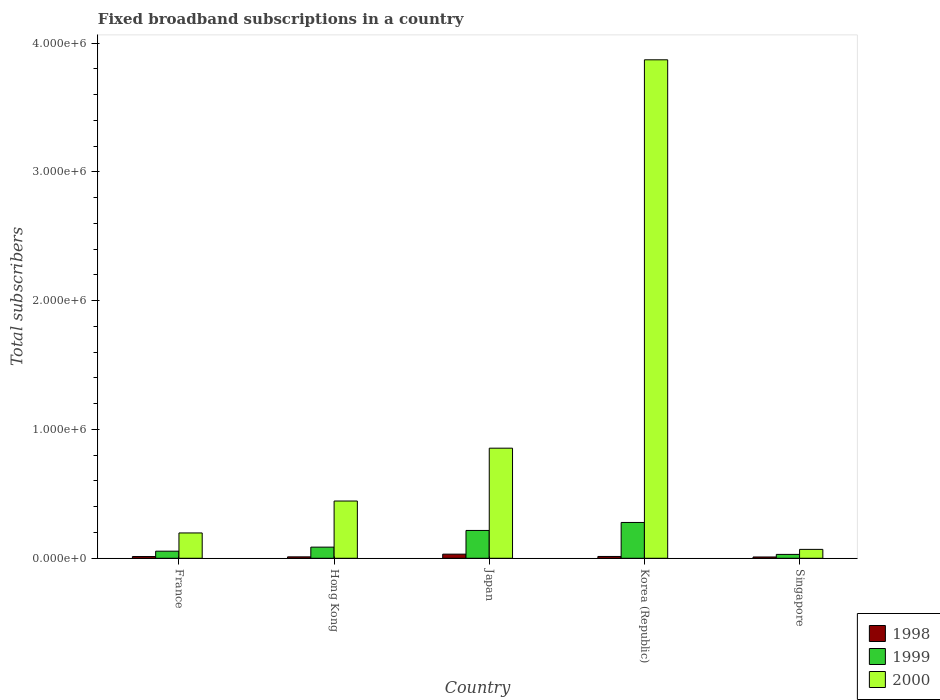How many groups of bars are there?
Your answer should be very brief. 5. Are the number of bars on each tick of the X-axis equal?
Provide a short and direct response. Yes. How many bars are there on the 3rd tick from the left?
Your answer should be very brief. 3. In how many cases, is the number of bars for a given country not equal to the number of legend labels?
Your answer should be compact. 0. What is the number of broadband subscriptions in 1999 in Singapore?
Your answer should be very brief. 3.00e+04. Across all countries, what is the maximum number of broadband subscriptions in 1999?
Ensure brevity in your answer.  2.78e+05. Across all countries, what is the minimum number of broadband subscriptions in 2000?
Your response must be concise. 6.90e+04. In which country was the number of broadband subscriptions in 1999 maximum?
Keep it short and to the point. Korea (Republic). In which country was the number of broadband subscriptions in 2000 minimum?
Your response must be concise. Singapore. What is the total number of broadband subscriptions in 2000 in the graph?
Your answer should be compact. 5.43e+06. What is the difference between the number of broadband subscriptions in 1998 in France and that in Hong Kong?
Offer a very short reply. 2464. What is the difference between the number of broadband subscriptions in 2000 in Singapore and the number of broadband subscriptions in 1999 in Japan?
Give a very brief answer. -1.47e+05. What is the average number of broadband subscriptions in 1999 per country?
Ensure brevity in your answer.  1.33e+05. What is the difference between the number of broadband subscriptions of/in 1999 and number of broadband subscriptions of/in 1998 in Hong Kong?
Offer a terse response. 7.55e+04. What is the ratio of the number of broadband subscriptions in 1999 in France to that in Singapore?
Ensure brevity in your answer.  1.83. Is the difference between the number of broadband subscriptions in 1999 in Korea (Republic) and Singapore greater than the difference between the number of broadband subscriptions in 1998 in Korea (Republic) and Singapore?
Make the answer very short. Yes. What is the difference between the highest and the second highest number of broadband subscriptions in 1998?
Offer a terse response. 1.85e+04. What is the difference between the highest and the lowest number of broadband subscriptions in 1999?
Make the answer very short. 2.48e+05. What does the 1st bar from the left in Japan represents?
Give a very brief answer. 1998. What does the 2nd bar from the right in Hong Kong represents?
Provide a short and direct response. 1999. How many bars are there?
Give a very brief answer. 15. Does the graph contain any zero values?
Ensure brevity in your answer.  No. Where does the legend appear in the graph?
Your response must be concise. Bottom right. What is the title of the graph?
Provide a succinct answer. Fixed broadband subscriptions in a country. What is the label or title of the X-axis?
Offer a very short reply. Country. What is the label or title of the Y-axis?
Your answer should be very brief. Total subscribers. What is the Total subscribers in 1998 in France?
Provide a short and direct response. 1.35e+04. What is the Total subscribers of 1999 in France?
Keep it short and to the point. 5.50e+04. What is the Total subscribers in 2000 in France?
Provide a succinct answer. 1.97e+05. What is the Total subscribers of 1998 in Hong Kong?
Offer a terse response. 1.10e+04. What is the Total subscribers of 1999 in Hong Kong?
Make the answer very short. 8.65e+04. What is the Total subscribers of 2000 in Hong Kong?
Your response must be concise. 4.44e+05. What is the Total subscribers in 1998 in Japan?
Your answer should be very brief. 3.20e+04. What is the Total subscribers of 1999 in Japan?
Your answer should be compact. 2.16e+05. What is the Total subscribers of 2000 in Japan?
Your response must be concise. 8.55e+05. What is the Total subscribers in 1998 in Korea (Republic)?
Your answer should be compact. 1.40e+04. What is the Total subscribers of 1999 in Korea (Republic)?
Give a very brief answer. 2.78e+05. What is the Total subscribers in 2000 in Korea (Republic)?
Ensure brevity in your answer.  3.87e+06. What is the Total subscribers of 1999 in Singapore?
Your response must be concise. 3.00e+04. What is the Total subscribers of 2000 in Singapore?
Your response must be concise. 6.90e+04. Across all countries, what is the maximum Total subscribers in 1998?
Provide a short and direct response. 3.20e+04. Across all countries, what is the maximum Total subscribers of 1999?
Your answer should be very brief. 2.78e+05. Across all countries, what is the maximum Total subscribers in 2000?
Keep it short and to the point. 3.87e+06. Across all countries, what is the minimum Total subscribers in 1998?
Keep it short and to the point. 10000. Across all countries, what is the minimum Total subscribers in 2000?
Make the answer very short. 6.90e+04. What is the total Total subscribers of 1998 in the graph?
Your answer should be compact. 8.05e+04. What is the total Total subscribers of 1999 in the graph?
Ensure brevity in your answer.  6.65e+05. What is the total Total subscribers of 2000 in the graph?
Your response must be concise. 5.43e+06. What is the difference between the Total subscribers in 1998 in France and that in Hong Kong?
Offer a terse response. 2464. What is the difference between the Total subscribers of 1999 in France and that in Hong Kong?
Offer a terse response. -3.15e+04. What is the difference between the Total subscribers of 2000 in France and that in Hong Kong?
Make the answer very short. -2.48e+05. What is the difference between the Total subscribers in 1998 in France and that in Japan?
Provide a short and direct response. -1.85e+04. What is the difference between the Total subscribers of 1999 in France and that in Japan?
Your response must be concise. -1.61e+05. What is the difference between the Total subscribers of 2000 in France and that in Japan?
Your answer should be very brief. -6.58e+05. What is the difference between the Total subscribers in 1998 in France and that in Korea (Republic)?
Make the answer very short. -536. What is the difference between the Total subscribers of 1999 in France and that in Korea (Republic)?
Ensure brevity in your answer.  -2.23e+05. What is the difference between the Total subscribers of 2000 in France and that in Korea (Republic)?
Keep it short and to the point. -3.67e+06. What is the difference between the Total subscribers of 1998 in France and that in Singapore?
Ensure brevity in your answer.  3464. What is the difference between the Total subscribers of 1999 in France and that in Singapore?
Your answer should be compact. 2.50e+04. What is the difference between the Total subscribers in 2000 in France and that in Singapore?
Keep it short and to the point. 1.28e+05. What is the difference between the Total subscribers of 1998 in Hong Kong and that in Japan?
Provide a succinct answer. -2.10e+04. What is the difference between the Total subscribers in 1999 in Hong Kong and that in Japan?
Provide a short and direct response. -1.30e+05. What is the difference between the Total subscribers of 2000 in Hong Kong and that in Japan?
Offer a very short reply. -4.10e+05. What is the difference between the Total subscribers of 1998 in Hong Kong and that in Korea (Republic)?
Your answer should be very brief. -3000. What is the difference between the Total subscribers of 1999 in Hong Kong and that in Korea (Republic)?
Provide a succinct answer. -1.92e+05. What is the difference between the Total subscribers in 2000 in Hong Kong and that in Korea (Republic)?
Offer a terse response. -3.43e+06. What is the difference between the Total subscribers of 1999 in Hong Kong and that in Singapore?
Give a very brief answer. 5.65e+04. What is the difference between the Total subscribers in 2000 in Hong Kong and that in Singapore?
Offer a terse response. 3.75e+05. What is the difference between the Total subscribers in 1998 in Japan and that in Korea (Republic)?
Give a very brief answer. 1.80e+04. What is the difference between the Total subscribers in 1999 in Japan and that in Korea (Republic)?
Provide a short and direct response. -6.20e+04. What is the difference between the Total subscribers of 2000 in Japan and that in Korea (Republic)?
Your answer should be compact. -3.02e+06. What is the difference between the Total subscribers in 1998 in Japan and that in Singapore?
Provide a short and direct response. 2.20e+04. What is the difference between the Total subscribers in 1999 in Japan and that in Singapore?
Your answer should be compact. 1.86e+05. What is the difference between the Total subscribers in 2000 in Japan and that in Singapore?
Provide a short and direct response. 7.86e+05. What is the difference between the Total subscribers of 1998 in Korea (Republic) and that in Singapore?
Make the answer very short. 4000. What is the difference between the Total subscribers in 1999 in Korea (Republic) and that in Singapore?
Keep it short and to the point. 2.48e+05. What is the difference between the Total subscribers in 2000 in Korea (Republic) and that in Singapore?
Provide a short and direct response. 3.80e+06. What is the difference between the Total subscribers of 1998 in France and the Total subscribers of 1999 in Hong Kong?
Offer a very short reply. -7.30e+04. What is the difference between the Total subscribers in 1998 in France and the Total subscribers in 2000 in Hong Kong?
Your answer should be compact. -4.31e+05. What is the difference between the Total subscribers in 1999 in France and the Total subscribers in 2000 in Hong Kong?
Your answer should be compact. -3.89e+05. What is the difference between the Total subscribers in 1998 in France and the Total subscribers in 1999 in Japan?
Your answer should be very brief. -2.03e+05. What is the difference between the Total subscribers in 1998 in France and the Total subscribers in 2000 in Japan?
Provide a succinct answer. -8.41e+05. What is the difference between the Total subscribers of 1999 in France and the Total subscribers of 2000 in Japan?
Keep it short and to the point. -8.00e+05. What is the difference between the Total subscribers in 1998 in France and the Total subscribers in 1999 in Korea (Republic)?
Ensure brevity in your answer.  -2.65e+05. What is the difference between the Total subscribers in 1998 in France and the Total subscribers in 2000 in Korea (Republic)?
Offer a very short reply. -3.86e+06. What is the difference between the Total subscribers in 1999 in France and the Total subscribers in 2000 in Korea (Republic)?
Give a very brief answer. -3.82e+06. What is the difference between the Total subscribers in 1998 in France and the Total subscribers in 1999 in Singapore?
Offer a terse response. -1.65e+04. What is the difference between the Total subscribers in 1998 in France and the Total subscribers in 2000 in Singapore?
Keep it short and to the point. -5.55e+04. What is the difference between the Total subscribers of 1999 in France and the Total subscribers of 2000 in Singapore?
Offer a very short reply. -1.40e+04. What is the difference between the Total subscribers of 1998 in Hong Kong and the Total subscribers of 1999 in Japan?
Your answer should be compact. -2.05e+05. What is the difference between the Total subscribers in 1998 in Hong Kong and the Total subscribers in 2000 in Japan?
Your answer should be very brief. -8.44e+05. What is the difference between the Total subscribers in 1999 in Hong Kong and the Total subscribers in 2000 in Japan?
Offer a very short reply. -7.68e+05. What is the difference between the Total subscribers in 1998 in Hong Kong and the Total subscribers in 1999 in Korea (Republic)?
Provide a succinct answer. -2.67e+05. What is the difference between the Total subscribers in 1998 in Hong Kong and the Total subscribers in 2000 in Korea (Republic)?
Make the answer very short. -3.86e+06. What is the difference between the Total subscribers in 1999 in Hong Kong and the Total subscribers in 2000 in Korea (Republic)?
Your answer should be compact. -3.78e+06. What is the difference between the Total subscribers of 1998 in Hong Kong and the Total subscribers of 1999 in Singapore?
Your response must be concise. -1.90e+04. What is the difference between the Total subscribers of 1998 in Hong Kong and the Total subscribers of 2000 in Singapore?
Offer a terse response. -5.80e+04. What is the difference between the Total subscribers in 1999 in Hong Kong and the Total subscribers in 2000 in Singapore?
Offer a terse response. 1.75e+04. What is the difference between the Total subscribers of 1998 in Japan and the Total subscribers of 1999 in Korea (Republic)?
Provide a short and direct response. -2.46e+05. What is the difference between the Total subscribers of 1998 in Japan and the Total subscribers of 2000 in Korea (Republic)?
Keep it short and to the point. -3.84e+06. What is the difference between the Total subscribers in 1999 in Japan and the Total subscribers in 2000 in Korea (Republic)?
Your answer should be compact. -3.65e+06. What is the difference between the Total subscribers of 1998 in Japan and the Total subscribers of 1999 in Singapore?
Your response must be concise. 2000. What is the difference between the Total subscribers in 1998 in Japan and the Total subscribers in 2000 in Singapore?
Offer a very short reply. -3.70e+04. What is the difference between the Total subscribers of 1999 in Japan and the Total subscribers of 2000 in Singapore?
Your response must be concise. 1.47e+05. What is the difference between the Total subscribers of 1998 in Korea (Republic) and the Total subscribers of 1999 in Singapore?
Your answer should be very brief. -1.60e+04. What is the difference between the Total subscribers in 1998 in Korea (Republic) and the Total subscribers in 2000 in Singapore?
Make the answer very short. -5.50e+04. What is the difference between the Total subscribers in 1999 in Korea (Republic) and the Total subscribers in 2000 in Singapore?
Your answer should be compact. 2.09e+05. What is the average Total subscribers in 1998 per country?
Provide a short and direct response. 1.61e+04. What is the average Total subscribers in 1999 per country?
Keep it short and to the point. 1.33e+05. What is the average Total subscribers of 2000 per country?
Your answer should be compact. 1.09e+06. What is the difference between the Total subscribers of 1998 and Total subscribers of 1999 in France?
Your answer should be compact. -4.15e+04. What is the difference between the Total subscribers of 1998 and Total subscribers of 2000 in France?
Ensure brevity in your answer.  -1.83e+05. What is the difference between the Total subscribers in 1999 and Total subscribers in 2000 in France?
Your response must be concise. -1.42e+05. What is the difference between the Total subscribers in 1998 and Total subscribers in 1999 in Hong Kong?
Give a very brief answer. -7.55e+04. What is the difference between the Total subscribers in 1998 and Total subscribers in 2000 in Hong Kong?
Your answer should be compact. -4.33e+05. What is the difference between the Total subscribers in 1999 and Total subscribers in 2000 in Hong Kong?
Offer a very short reply. -3.58e+05. What is the difference between the Total subscribers of 1998 and Total subscribers of 1999 in Japan?
Keep it short and to the point. -1.84e+05. What is the difference between the Total subscribers in 1998 and Total subscribers in 2000 in Japan?
Offer a very short reply. -8.23e+05. What is the difference between the Total subscribers of 1999 and Total subscribers of 2000 in Japan?
Your response must be concise. -6.39e+05. What is the difference between the Total subscribers in 1998 and Total subscribers in 1999 in Korea (Republic)?
Ensure brevity in your answer.  -2.64e+05. What is the difference between the Total subscribers of 1998 and Total subscribers of 2000 in Korea (Republic)?
Keep it short and to the point. -3.86e+06. What is the difference between the Total subscribers of 1999 and Total subscribers of 2000 in Korea (Republic)?
Offer a very short reply. -3.59e+06. What is the difference between the Total subscribers of 1998 and Total subscribers of 2000 in Singapore?
Offer a terse response. -5.90e+04. What is the difference between the Total subscribers in 1999 and Total subscribers in 2000 in Singapore?
Offer a very short reply. -3.90e+04. What is the ratio of the Total subscribers in 1998 in France to that in Hong Kong?
Offer a very short reply. 1.22. What is the ratio of the Total subscribers in 1999 in France to that in Hong Kong?
Provide a succinct answer. 0.64. What is the ratio of the Total subscribers in 2000 in France to that in Hong Kong?
Your answer should be very brief. 0.44. What is the ratio of the Total subscribers of 1998 in France to that in Japan?
Your response must be concise. 0.42. What is the ratio of the Total subscribers of 1999 in France to that in Japan?
Provide a succinct answer. 0.25. What is the ratio of the Total subscribers in 2000 in France to that in Japan?
Your answer should be very brief. 0.23. What is the ratio of the Total subscribers in 1998 in France to that in Korea (Republic)?
Offer a terse response. 0.96. What is the ratio of the Total subscribers of 1999 in France to that in Korea (Republic)?
Provide a succinct answer. 0.2. What is the ratio of the Total subscribers in 2000 in France to that in Korea (Republic)?
Provide a succinct answer. 0.05. What is the ratio of the Total subscribers of 1998 in France to that in Singapore?
Provide a short and direct response. 1.35. What is the ratio of the Total subscribers in 1999 in France to that in Singapore?
Provide a succinct answer. 1.83. What is the ratio of the Total subscribers of 2000 in France to that in Singapore?
Ensure brevity in your answer.  2.85. What is the ratio of the Total subscribers of 1998 in Hong Kong to that in Japan?
Ensure brevity in your answer.  0.34. What is the ratio of the Total subscribers of 1999 in Hong Kong to that in Japan?
Provide a succinct answer. 0.4. What is the ratio of the Total subscribers of 2000 in Hong Kong to that in Japan?
Your answer should be very brief. 0.52. What is the ratio of the Total subscribers in 1998 in Hong Kong to that in Korea (Republic)?
Provide a short and direct response. 0.79. What is the ratio of the Total subscribers of 1999 in Hong Kong to that in Korea (Republic)?
Your answer should be very brief. 0.31. What is the ratio of the Total subscribers in 2000 in Hong Kong to that in Korea (Republic)?
Give a very brief answer. 0.11. What is the ratio of the Total subscribers in 1998 in Hong Kong to that in Singapore?
Keep it short and to the point. 1.1. What is the ratio of the Total subscribers of 1999 in Hong Kong to that in Singapore?
Provide a succinct answer. 2.88. What is the ratio of the Total subscribers of 2000 in Hong Kong to that in Singapore?
Give a very brief answer. 6.44. What is the ratio of the Total subscribers of 1998 in Japan to that in Korea (Republic)?
Keep it short and to the point. 2.29. What is the ratio of the Total subscribers in 1999 in Japan to that in Korea (Republic)?
Offer a very short reply. 0.78. What is the ratio of the Total subscribers in 2000 in Japan to that in Korea (Republic)?
Ensure brevity in your answer.  0.22. What is the ratio of the Total subscribers in 1998 in Japan to that in Singapore?
Ensure brevity in your answer.  3.2. What is the ratio of the Total subscribers of 1999 in Japan to that in Singapore?
Your answer should be very brief. 7.2. What is the ratio of the Total subscribers of 2000 in Japan to that in Singapore?
Provide a short and direct response. 12.39. What is the ratio of the Total subscribers in 1998 in Korea (Republic) to that in Singapore?
Provide a succinct answer. 1.4. What is the ratio of the Total subscribers of 1999 in Korea (Republic) to that in Singapore?
Give a very brief answer. 9.27. What is the ratio of the Total subscribers in 2000 in Korea (Republic) to that in Singapore?
Give a very brief answer. 56.09. What is the difference between the highest and the second highest Total subscribers in 1998?
Offer a terse response. 1.80e+04. What is the difference between the highest and the second highest Total subscribers in 1999?
Offer a terse response. 6.20e+04. What is the difference between the highest and the second highest Total subscribers in 2000?
Provide a succinct answer. 3.02e+06. What is the difference between the highest and the lowest Total subscribers in 1998?
Offer a terse response. 2.20e+04. What is the difference between the highest and the lowest Total subscribers of 1999?
Provide a succinct answer. 2.48e+05. What is the difference between the highest and the lowest Total subscribers of 2000?
Offer a terse response. 3.80e+06. 